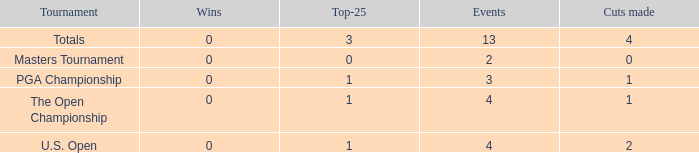How many cuts did he make in the tournament with 3 top 25s and under 13 events? None. 